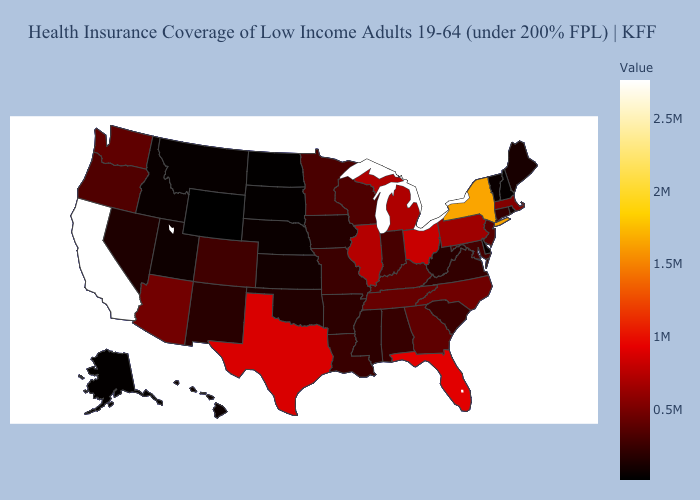Which states hav the highest value in the MidWest?
Give a very brief answer. Ohio. Does Wyoming have the lowest value in the USA?
Write a very short answer. Yes. Does Wyoming have the lowest value in the USA?
Be succinct. Yes. Which states hav the highest value in the South?
Quick response, please. Florida. Among the states that border Mississippi , does Arkansas have the lowest value?
Give a very brief answer. Yes. 